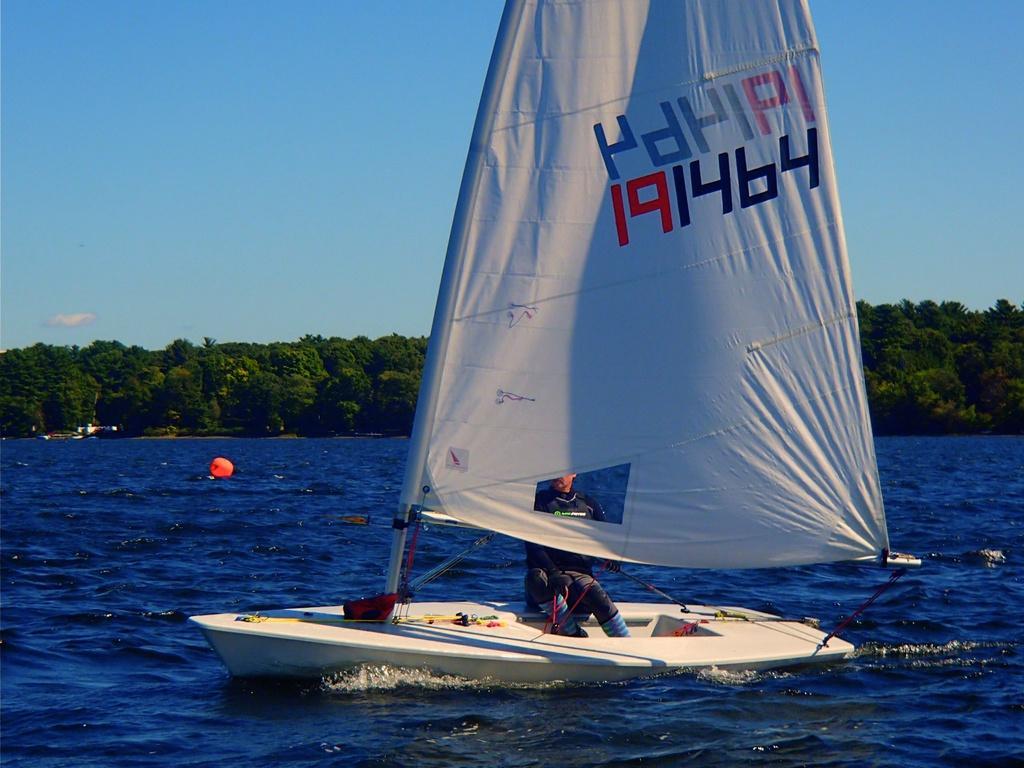Can you describe this image briefly? In this image in the center there is one boat, in the boat there is one person sitting and there is one pole and board. And at the bottom there is a river, and in the background there are some trees. At the top there is sky. 